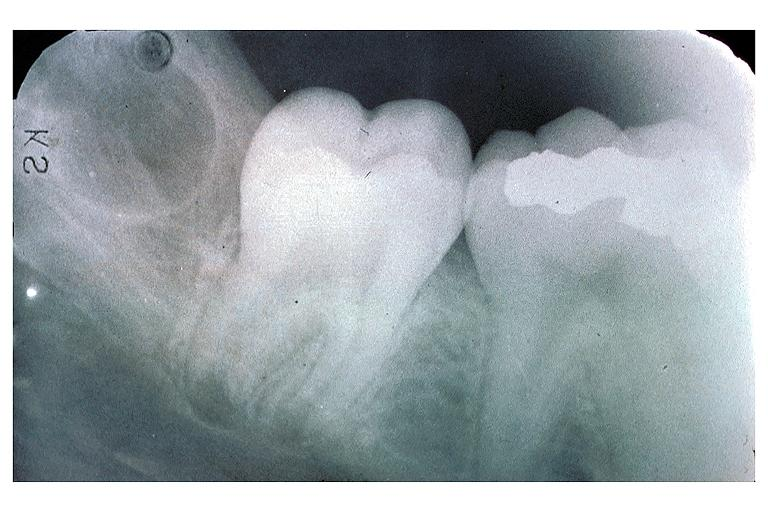s oral present?
Answer the question using a single word or phrase. Yes 